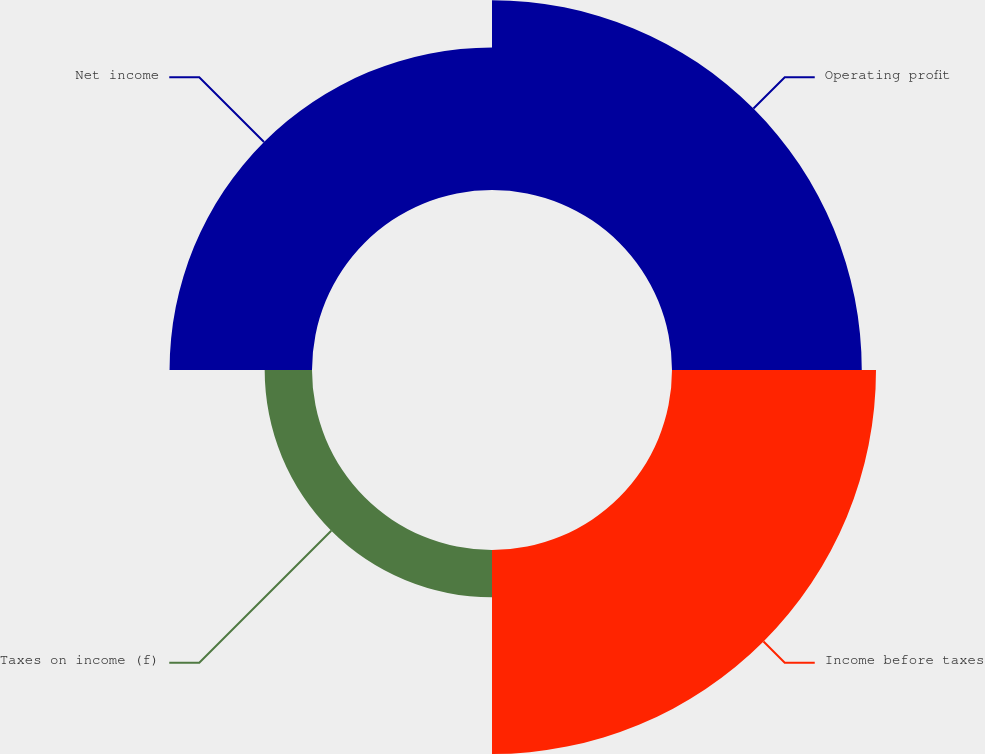Convert chart. <chart><loc_0><loc_0><loc_500><loc_500><pie_chart><fcel>Operating profit<fcel>Income before taxes<fcel>Taxes on income (f)<fcel>Net income<nl><fcel>32.52%<fcel>34.96%<fcel>8.11%<fcel>24.41%<nl></chart> 